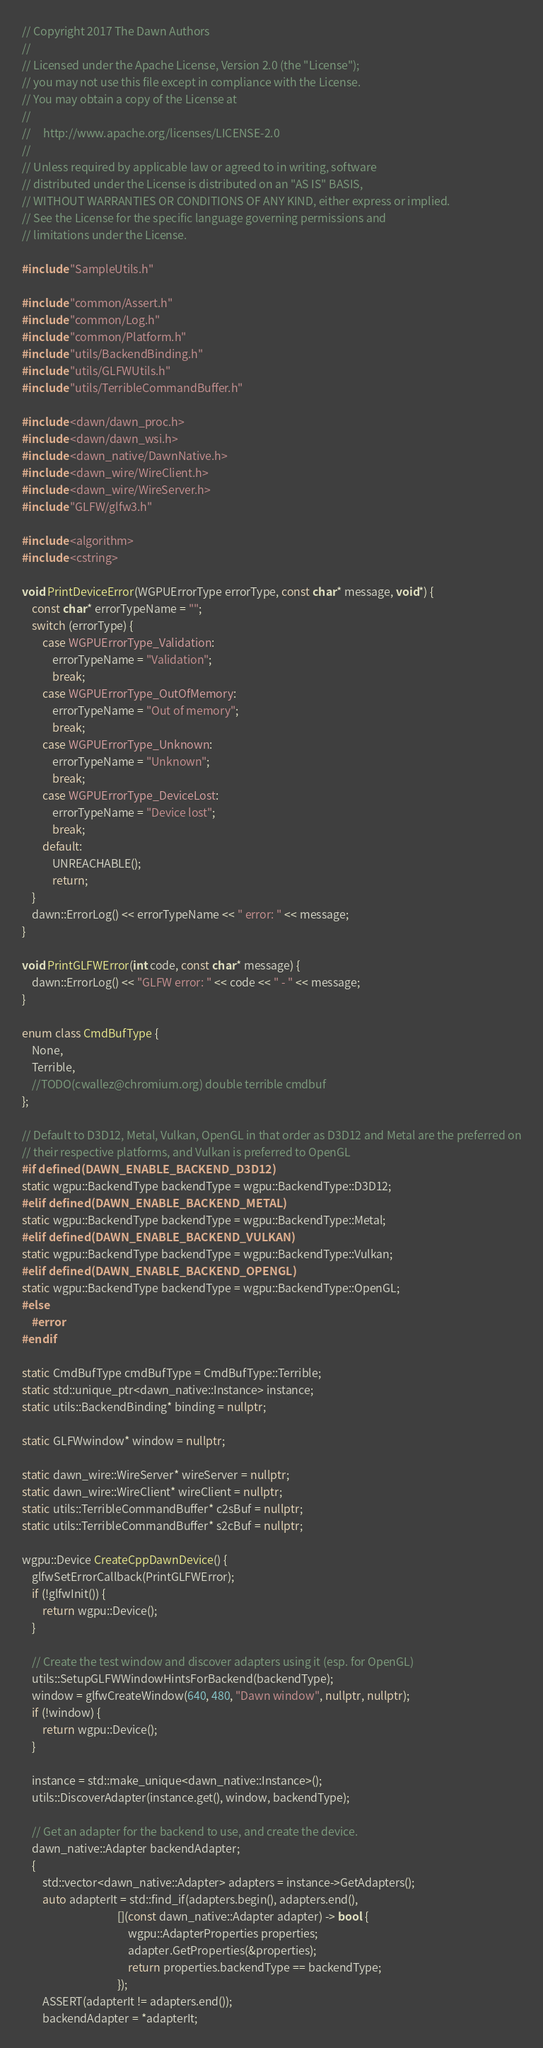<code> <loc_0><loc_0><loc_500><loc_500><_C++_>// Copyright 2017 The Dawn Authors
//
// Licensed under the Apache License, Version 2.0 (the "License");
// you may not use this file except in compliance with the License.
// You may obtain a copy of the License at
//
//     http://www.apache.org/licenses/LICENSE-2.0
//
// Unless required by applicable law or agreed to in writing, software
// distributed under the License is distributed on an "AS IS" BASIS,
// WITHOUT WARRANTIES OR CONDITIONS OF ANY KIND, either express or implied.
// See the License for the specific language governing permissions and
// limitations under the License.

#include "SampleUtils.h"

#include "common/Assert.h"
#include "common/Log.h"
#include "common/Platform.h"
#include "utils/BackendBinding.h"
#include "utils/GLFWUtils.h"
#include "utils/TerribleCommandBuffer.h"

#include <dawn/dawn_proc.h>
#include <dawn/dawn_wsi.h>
#include <dawn_native/DawnNative.h>
#include <dawn_wire/WireClient.h>
#include <dawn_wire/WireServer.h>
#include "GLFW/glfw3.h"

#include <algorithm>
#include <cstring>

void PrintDeviceError(WGPUErrorType errorType, const char* message, void*) {
    const char* errorTypeName = "";
    switch (errorType) {
        case WGPUErrorType_Validation:
            errorTypeName = "Validation";
            break;
        case WGPUErrorType_OutOfMemory:
            errorTypeName = "Out of memory";
            break;
        case WGPUErrorType_Unknown:
            errorTypeName = "Unknown";
            break;
        case WGPUErrorType_DeviceLost:
            errorTypeName = "Device lost";
            break;
        default:
            UNREACHABLE();
            return;
    }
    dawn::ErrorLog() << errorTypeName << " error: " << message;
}

void PrintGLFWError(int code, const char* message) {
    dawn::ErrorLog() << "GLFW error: " << code << " - " << message;
}

enum class CmdBufType {
    None,
    Terrible,
    //TODO(cwallez@chromium.org) double terrible cmdbuf
};

// Default to D3D12, Metal, Vulkan, OpenGL in that order as D3D12 and Metal are the preferred on
// their respective platforms, and Vulkan is preferred to OpenGL
#if defined(DAWN_ENABLE_BACKEND_D3D12)
static wgpu::BackendType backendType = wgpu::BackendType::D3D12;
#elif defined(DAWN_ENABLE_BACKEND_METAL)
static wgpu::BackendType backendType = wgpu::BackendType::Metal;
#elif defined(DAWN_ENABLE_BACKEND_VULKAN)
static wgpu::BackendType backendType = wgpu::BackendType::Vulkan;
#elif defined(DAWN_ENABLE_BACKEND_OPENGL)
static wgpu::BackendType backendType = wgpu::BackendType::OpenGL;
#else
    #error
#endif

static CmdBufType cmdBufType = CmdBufType::Terrible;
static std::unique_ptr<dawn_native::Instance> instance;
static utils::BackendBinding* binding = nullptr;

static GLFWwindow* window = nullptr;

static dawn_wire::WireServer* wireServer = nullptr;
static dawn_wire::WireClient* wireClient = nullptr;
static utils::TerribleCommandBuffer* c2sBuf = nullptr;
static utils::TerribleCommandBuffer* s2cBuf = nullptr;

wgpu::Device CreateCppDawnDevice() {
    glfwSetErrorCallback(PrintGLFWError);
    if (!glfwInit()) {
        return wgpu::Device();
    }

    // Create the test window and discover adapters using it (esp. for OpenGL)
    utils::SetupGLFWWindowHintsForBackend(backendType);
    window = glfwCreateWindow(640, 480, "Dawn window", nullptr, nullptr);
    if (!window) {
        return wgpu::Device();
    }

    instance = std::make_unique<dawn_native::Instance>();
    utils::DiscoverAdapter(instance.get(), window, backendType);

    // Get an adapter for the backend to use, and create the device.
    dawn_native::Adapter backendAdapter;
    {
        std::vector<dawn_native::Adapter> adapters = instance->GetAdapters();
        auto adapterIt = std::find_if(adapters.begin(), adapters.end(),
                                      [](const dawn_native::Adapter adapter) -> bool {
                                          wgpu::AdapterProperties properties;
                                          adapter.GetProperties(&properties);
                                          return properties.backendType == backendType;
                                      });
        ASSERT(adapterIt != adapters.end());
        backendAdapter = *adapterIt;</code> 